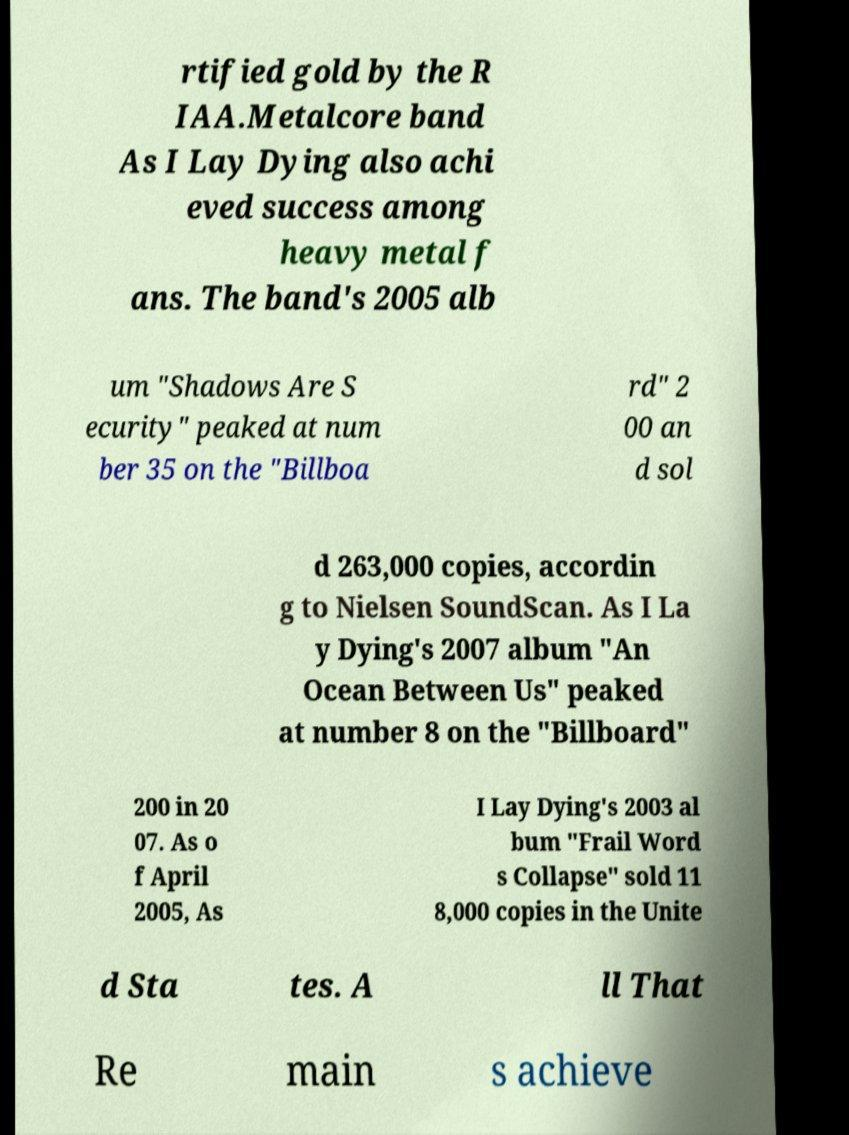Can you accurately transcribe the text from the provided image for me? rtified gold by the R IAA.Metalcore band As I Lay Dying also achi eved success among heavy metal f ans. The band's 2005 alb um "Shadows Are S ecurity" peaked at num ber 35 on the "Billboa rd" 2 00 an d sol d 263,000 copies, accordin g to Nielsen SoundScan. As I La y Dying's 2007 album "An Ocean Between Us" peaked at number 8 on the "Billboard" 200 in 20 07. As o f April 2005, As I Lay Dying's 2003 al bum "Frail Word s Collapse" sold 11 8,000 copies in the Unite d Sta tes. A ll That Re main s achieve 